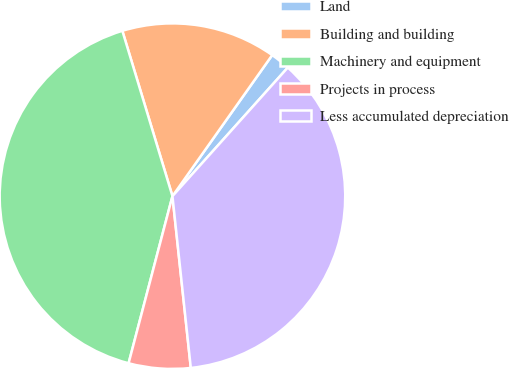Convert chart. <chart><loc_0><loc_0><loc_500><loc_500><pie_chart><fcel>Land<fcel>Building and building<fcel>Machinery and equipment<fcel>Projects in process<fcel>Less accumulated depreciation<nl><fcel>1.84%<fcel>14.48%<fcel>41.23%<fcel>5.78%<fcel>36.67%<nl></chart> 